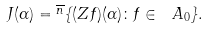<formula> <loc_0><loc_0><loc_500><loc_500>J ( \alpha ) = \overline { ^ { n } } \{ ( Z f ) ( \alpha ) \colon f \in \ A _ { 0 } \} .</formula> 